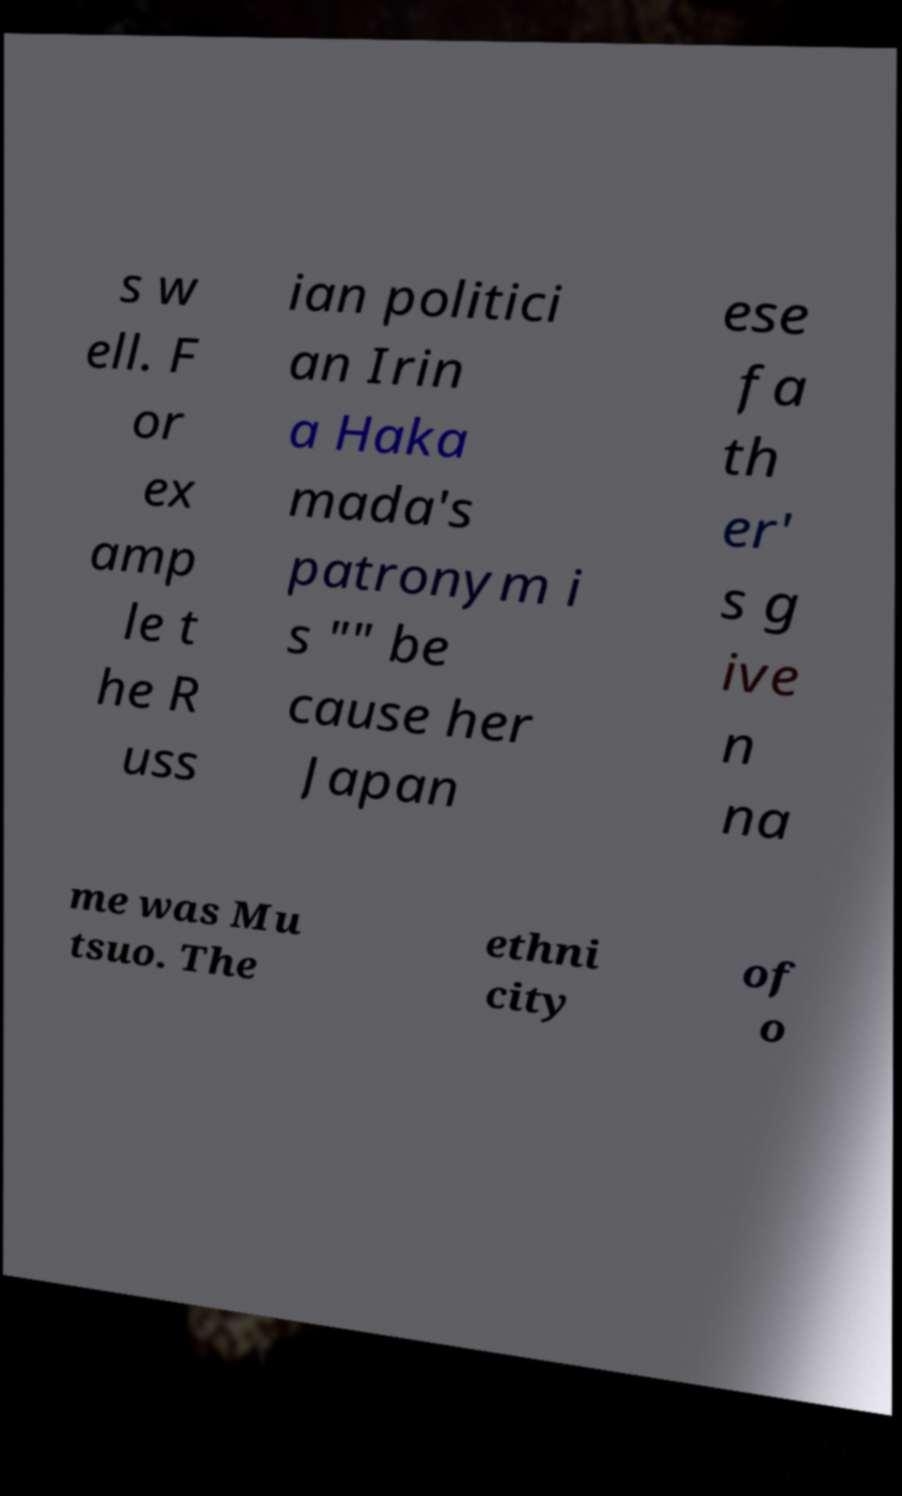Could you extract and type out the text from this image? s w ell. F or ex amp le t he R uss ian politici an Irin a Haka mada's patronym i s "" be cause her Japan ese fa th er' s g ive n na me was Mu tsuo. The ethni city of o 